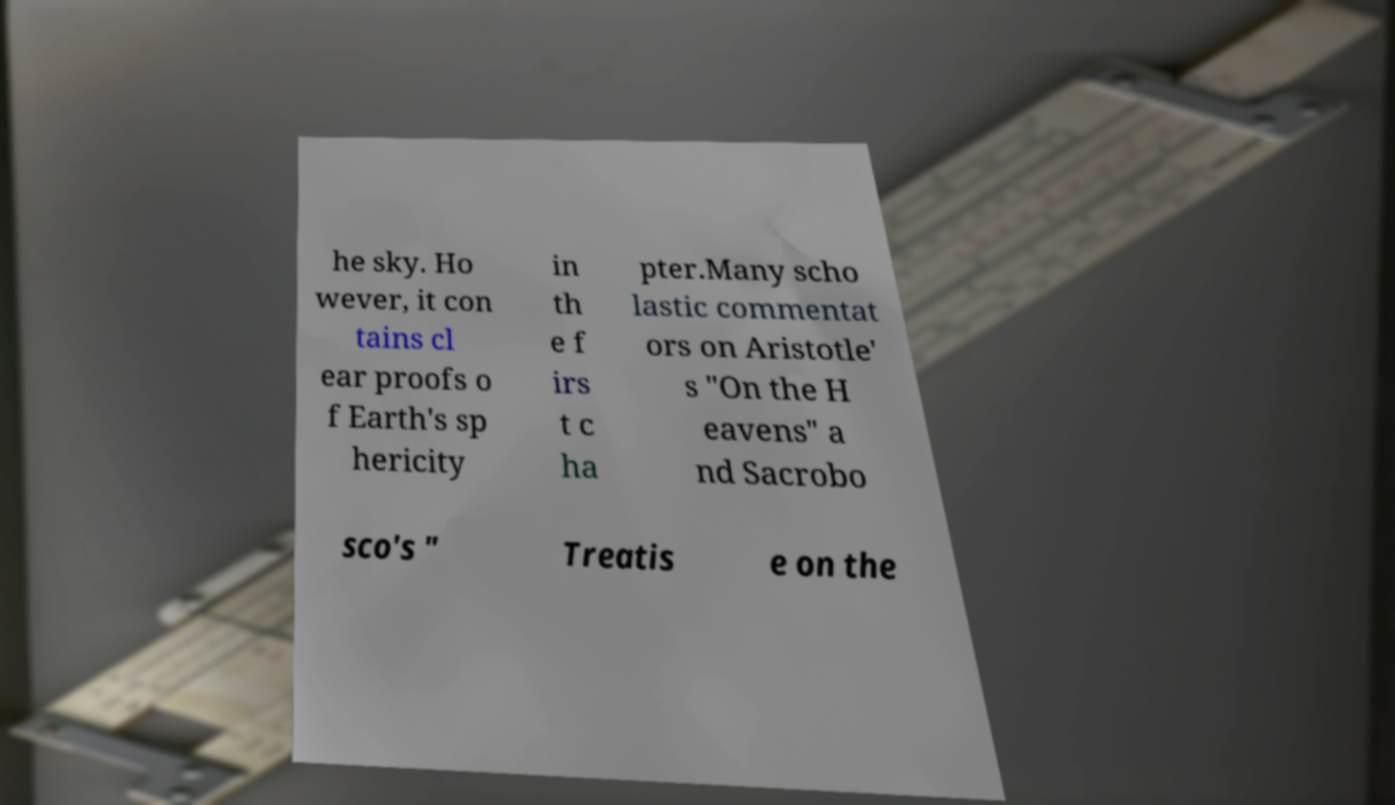Please read and relay the text visible in this image. What does it say? he sky. Ho wever, it con tains cl ear proofs o f Earth's sp hericity in th e f irs t c ha pter.Many scho lastic commentat ors on Aristotle' s "On the H eavens" a nd Sacrobo sco's " Treatis e on the 